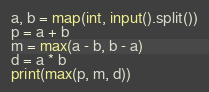Convert code to text. <code><loc_0><loc_0><loc_500><loc_500><_Python_>a, b = map(int, input().split())
p = a + b
m = max(a - b, b - a)
d = a * b
print(max(p, m, d))</code> 